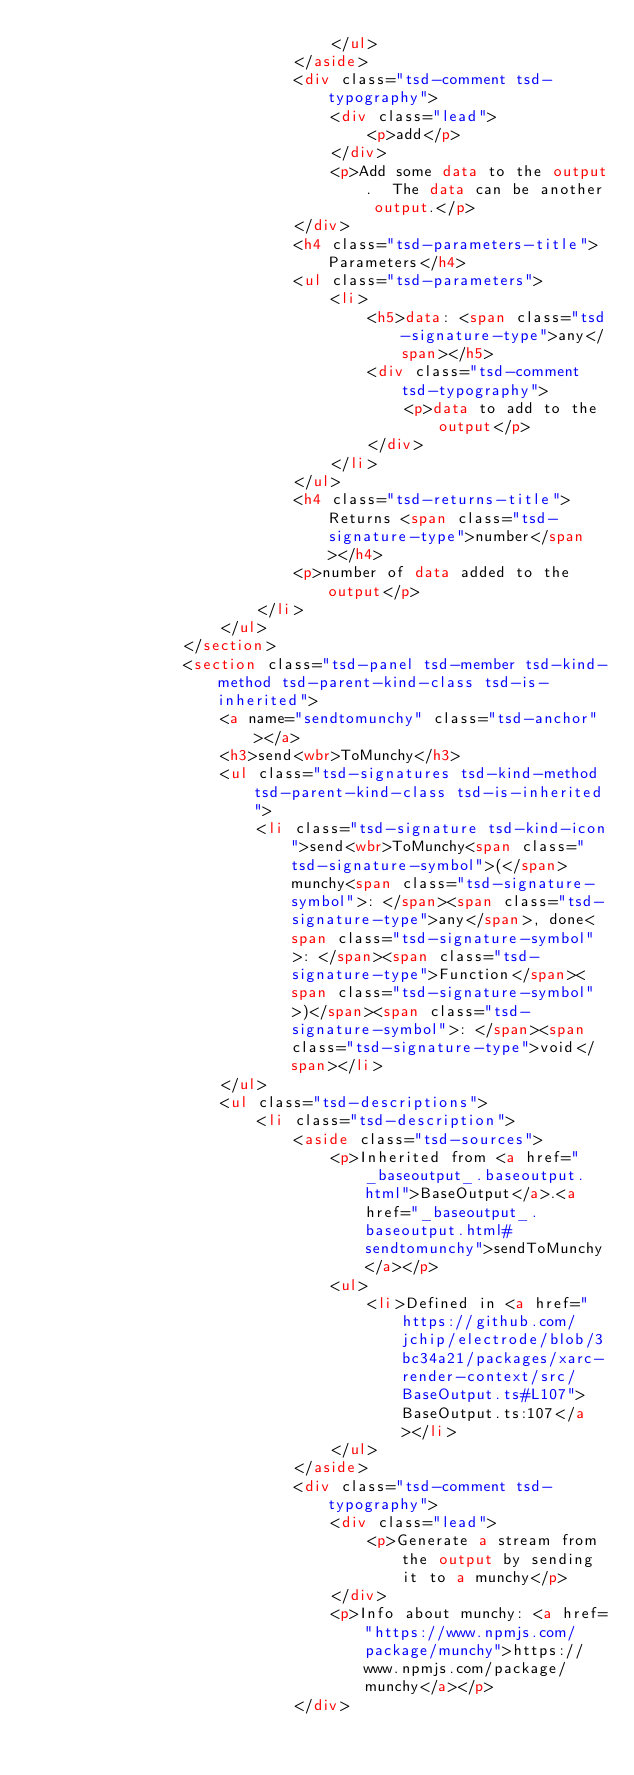Convert code to text. <code><loc_0><loc_0><loc_500><loc_500><_HTML_>								</ul>
							</aside>
							<div class="tsd-comment tsd-typography">
								<div class="lead">
									<p>add</p>
								</div>
								<p>Add some data to the output.  The data can be another output.</p>
							</div>
							<h4 class="tsd-parameters-title">Parameters</h4>
							<ul class="tsd-parameters">
								<li>
									<h5>data: <span class="tsd-signature-type">any</span></h5>
									<div class="tsd-comment tsd-typography">
										<p>data to add to the output</p>
									</div>
								</li>
							</ul>
							<h4 class="tsd-returns-title">Returns <span class="tsd-signature-type">number</span></h4>
							<p>number of data added to the output</p>
						</li>
					</ul>
				</section>
				<section class="tsd-panel tsd-member tsd-kind-method tsd-parent-kind-class tsd-is-inherited">
					<a name="sendtomunchy" class="tsd-anchor"></a>
					<h3>send<wbr>ToMunchy</h3>
					<ul class="tsd-signatures tsd-kind-method tsd-parent-kind-class tsd-is-inherited">
						<li class="tsd-signature tsd-kind-icon">send<wbr>ToMunchy<span class="tsd-signature-symbol">(</span>munchy<span class="tsd-signature-symbol">: </span><span class="tsd-signature-type">any</span>, done<span class="tsd-signature-symbol">: </span><span class="tsd-signature-type">Function</span><span class="tsd-signature-symbol">)</span><span class="tsd-signature-symbol">: </span><span class="tsd-signature-type">void</span></li>
					</ul>
					<ul class="tsd-descriptions">
						<li class="tsd-description">
							<aside class="tsd-sources">
								<p>Inherited from <a href="_baseoutput_.baseoutput.html">BaseOutput</a>.<a href="_baseoutput_.baseoutput.html#sendtomunchy">sendToMunchy</a></p>
								<ul>
									<li>Defined in <a href="https://github.com/jchip/electrode/blob/3bc34a21/packages/xarc-render-context/src/BaseOutput.ts#L107">BaseOutput.ts:107</a></li>
								</ul>
							</aside>
							<div class="tsd-comment tsd-typography">
								<div class="lead">
									<p>Generate a stream from the output by sending it to a munchy</p>
								</div>
								<p>Info about munchy: <a href="https://www.npmjs.com/package/munchy">https://www.npmjs.com/package/munchy</a></p>
							</div></code> 